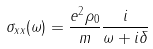<formula> <loc_0><loc_0><loc_500><loc_500>\sigma _ { x x } ( \omega ) = \frac { e ^ { 2 } \rho _ { 0 } } { m } \frac { i } { \omega + i \delta }</formula> 